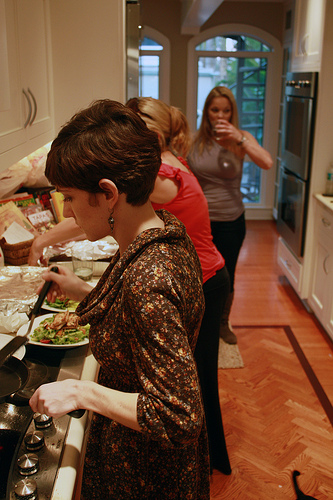Please provide the bounding box coordinate of the region this sentence describes: A plate full of food. [0.19, 0.61, 0.35, 0.7]. This box coordinates suggest the focus is on a plate filled with food, likely being prepared or consumed. 